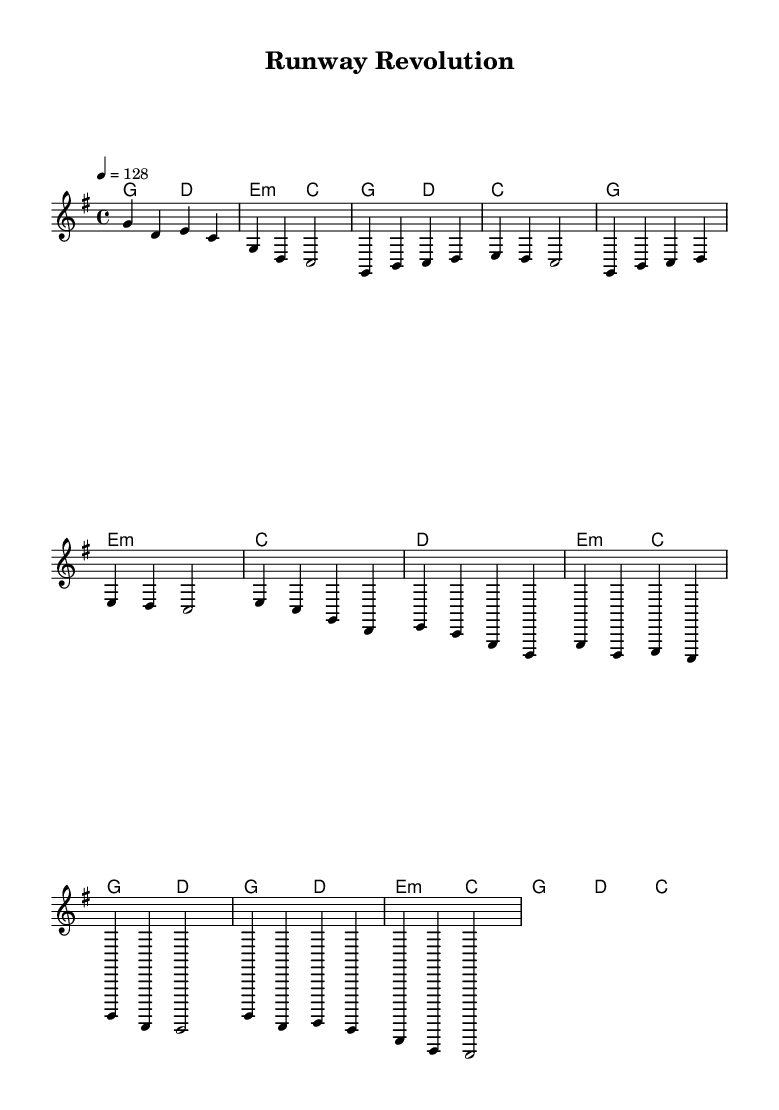What is the key signature of this music? The key signature is G major, indicated by one sharp (F#).
Answer: G major What is the time signature of this music? The time signature is 4/4, which means there are four beats in each measure and a quarter note receives one beat.
Answer: 4/4 What is the tempo of this music? The tempo marking states "4 = 128," meaning the quarter note is played at a speed of 128 beats per minute.
Answer: 128 How many measures are there in the chorus? The chorus, as noted in the structure, consists of four measures.
Answer: 4 What type of chord is used in the pre-chorus first measure? The first chord of the pre-chorus is an E minor chord, indicated by the "e:m" symbol.
Answer: E minor How does the melodic line of the verse section compare to the chorus in terms of pitch? The verse primarily stays within a G major scale but includes a more descending pattern; the chorus has an upward and dynamic feel, emphasizing higher pitches.
Answer: More ascending What transformation theme is depicted in the metaphorical context of this sheet music? The sheet music can be interpreted as showcasing the journey of personal evolution, reflected through shifts in melody and harmony that parallel K-Pop's theme of self-transformation.
Answer: Personal evolution 